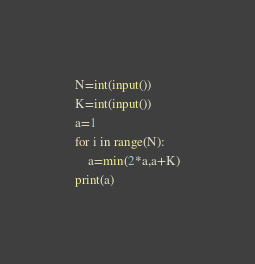<code> <loc_0><loc_0><loc_500><loc_500><_Python_>N=int(input())
K=int(input())
a=1
for i in range(N):
    a=min(2*a,a+K)
print(a)</code> 